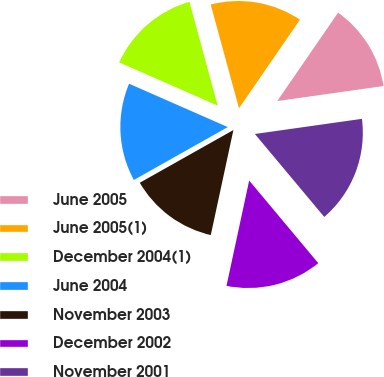Convert chart to OTSL. <chart><loc_0><loc_0><loc_500><loc_500><pie_chart><fcel>June 2005<fcel>June 2005(1)<fcel>December 2004(1)<fcel>June 2004<fcel>November 2003<fcel>December 2002<fcel>November 2001<nl><fcel>13.17%<fcel>13.83%<fcel>14.17%<fcel>14.75%<fcel>13.46%<fcel>14.46%<fcel>16.15%<nl></chart> 